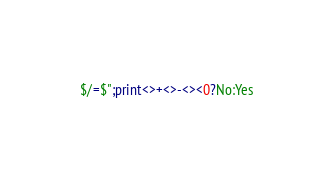Convert code to text. <code><loc_0><loc_0><loc_500><loc_500><_Perl_>$/=$";print<>+<>-<><0?No:Yes</code> 